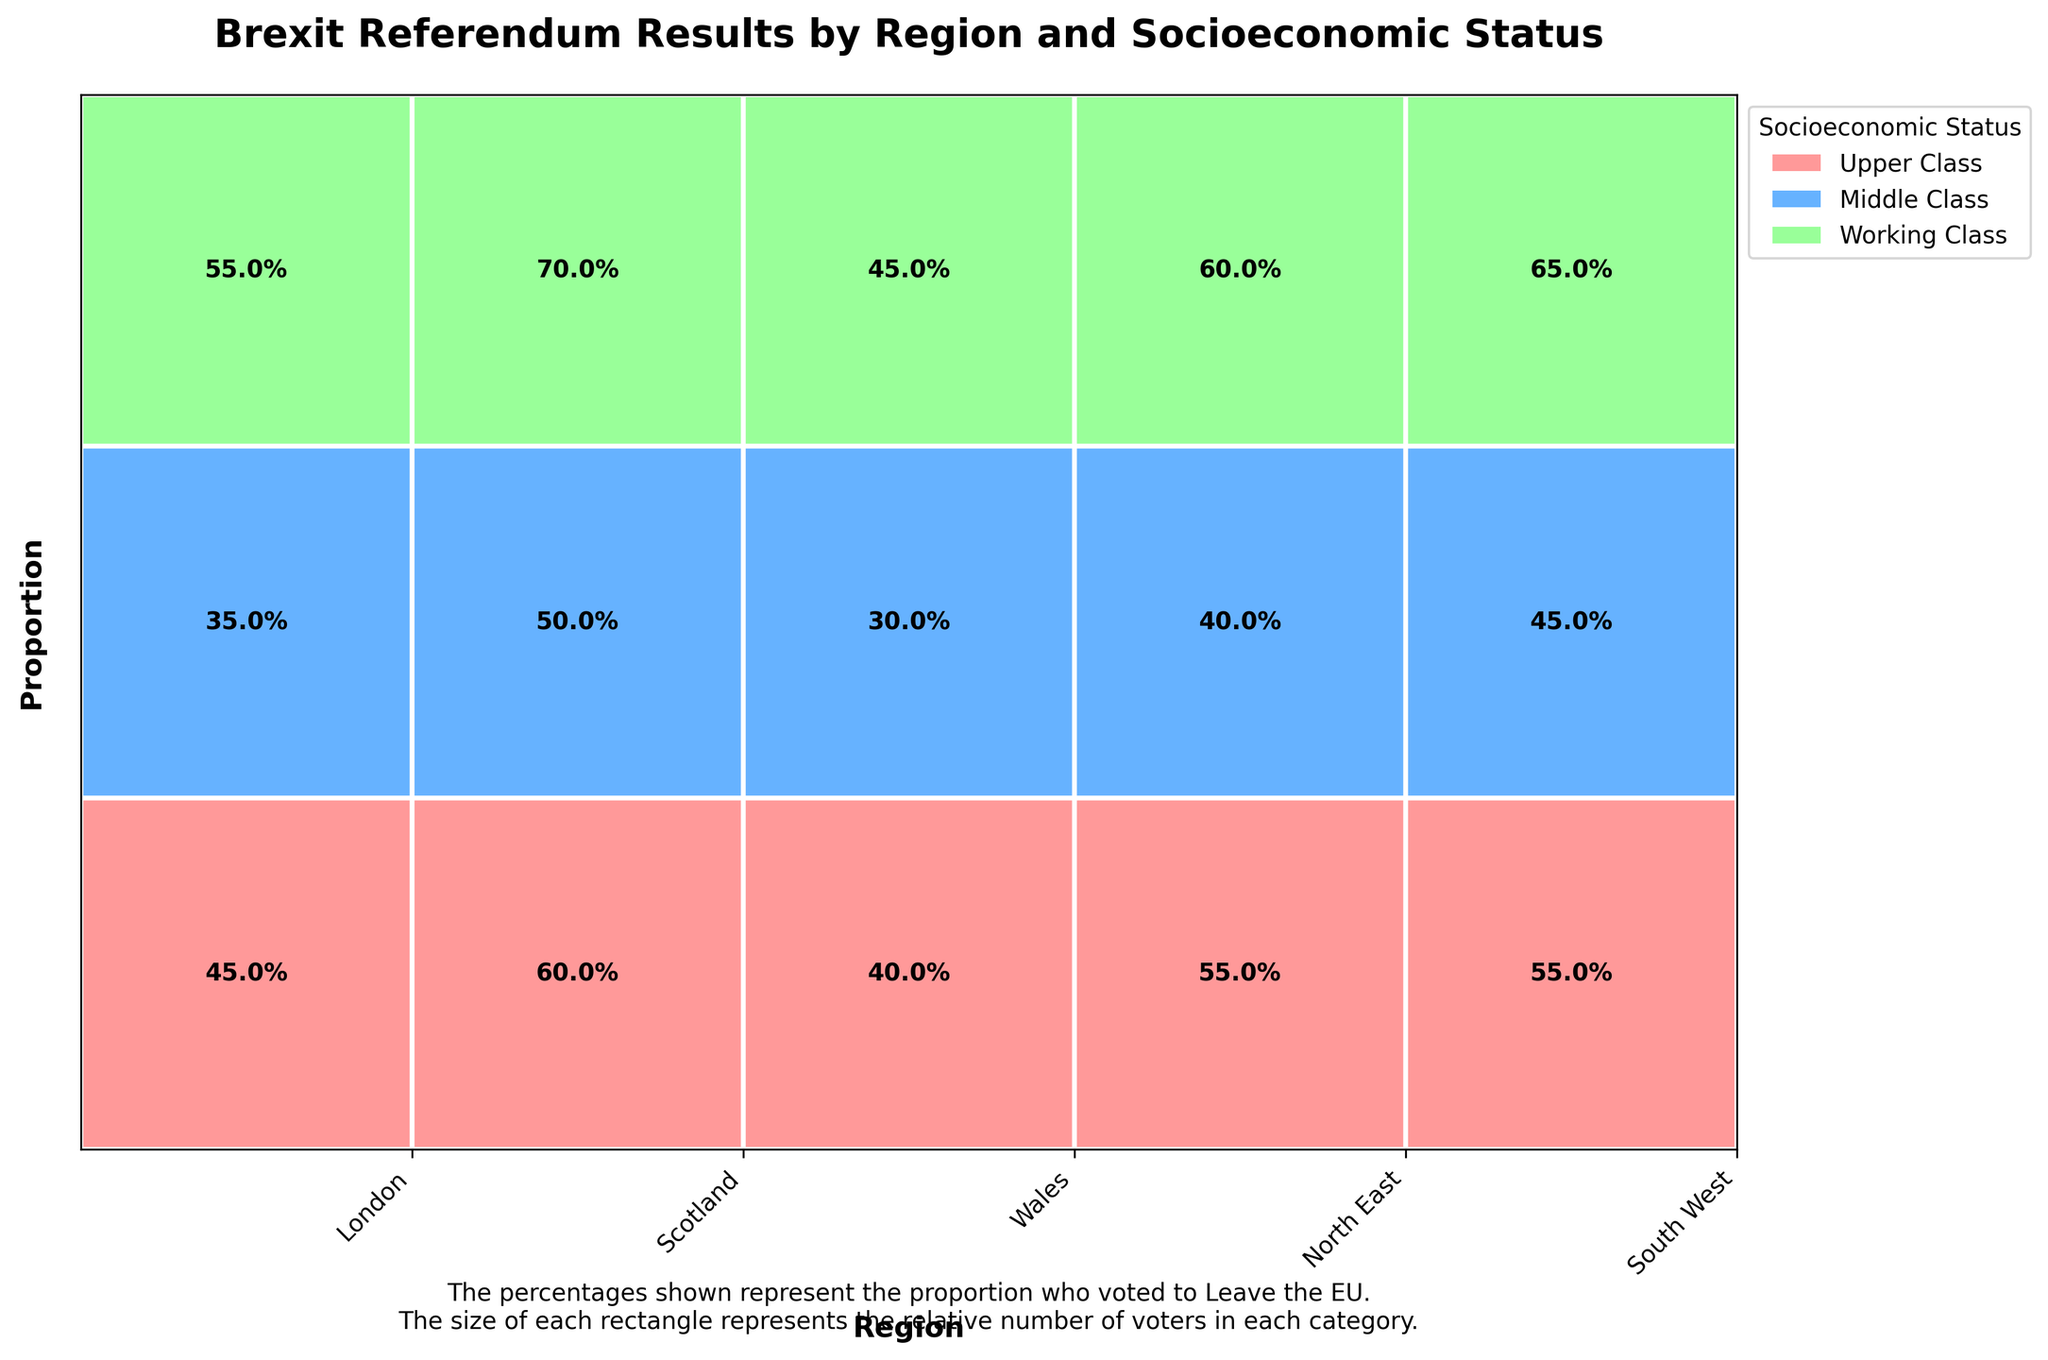How many regions are represented in the plot? The figure showcases results from multiple regions, each labeled on the x-axis. Counting these labels determines the total number of regions.
Answer: 5 Which socioeconomic status in London has the highest percentage of Leave votes? Each class within London has a marked percentage. By observing these labels, we can identify which has the highest percentage. The working class in London shows the highest percentage.
Answer: Working Class Comparing Upper Class in Scotland and Wales, which has a higher percentage of Remain votes? The percentages for Leave votes are visible for both classes in Scotland and Wales. Subtracting these from 100% yields the Remain votes, facilitating a direct comparison.
Answer: Scotland What is the percentage of Leave votes for the Working Class in Wales? The plot shows percentage values for different classes within regions. Identifying the label for Working Class in Wales provides the Leave percentage.
Answer: 65% Which region has the largest proportion of Middle Class voters who voted to Leave? The relative size of rectangles in the middle class category across regions can be compared visually. The largest rectangle indicates the region with the highest proportion.
Answer: North East What is the difference in Leave vote percentages between Middle Class in London and Scotland? The Leave percentages for the Middle Class in both regions are directly labeled. Subtracting these values gives the required difference.
Answer: 5% Which region shows the most similar voting pattern between Upper Class and Working Class? Evaluate the rectangles for Upper Class and Working Class within each region for similar shapes and sizes indicating similar voting patterns.
Answer: Scotland What socioeconomic status trend can be inferred in the South West based on Leave votes? Analysing the progression of Leave percentages across classes in South West shows an increasing pattern from Upper to Working Class.
Answer: Increasing trend How does the Upper Class voting pattern in North East compare to the Middle Class in the same region? The plot visually indicates that both classes in North East have rectangles of different sizes, and these rectangles help compare their voting patterns directly.
Answer: Lower for Upper Class Which region has the highest overall percentage of Remain votes among all socioeconomic statuses? Adding the proportions of Remain votes from all socioeconomic statuses in each region helps to identify which has the highest overall Remain vote proportion.
Answer: London 